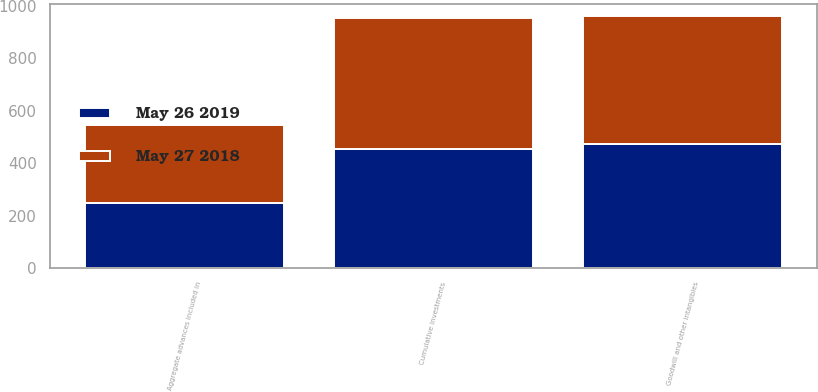Convert chart to OTSL. <chart><loc_0><loc_0><loc_500><loc_500><stacked_bar_chart><ecel><fcel>Cumulative investments<fcel>Goodwill and other intangibles<fcel>Aggregate advances included in<nl><fcel>May 26 2019<fcel>452.9<fcel>472.1<fcel>249<nl><fcel>May 27 2018<fcel>499.6<fcel>488.7<fcel>295.3<nl></chart> 